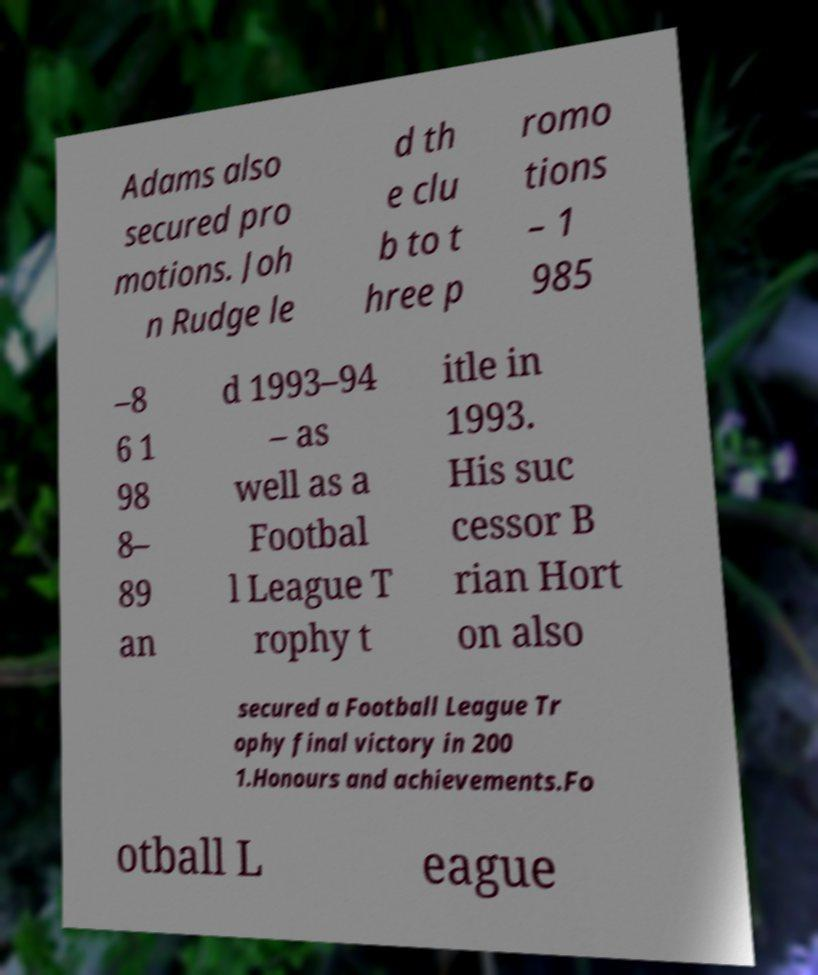Can you accurately transcribe the text from the provided image for me? Adams also secured pro motions. Joh n Rudge le d th e clu b to t hree p romo tions – 1 985 –8 6 1 98 8– 89 an d 1993–94 – as well as a Footbal l League T rophy t itle in 1993. His suc cessor B rian Hort on also secured a Football League Tr ophy final victory in 200 1.Honours and achievements.Fo otball L eague 